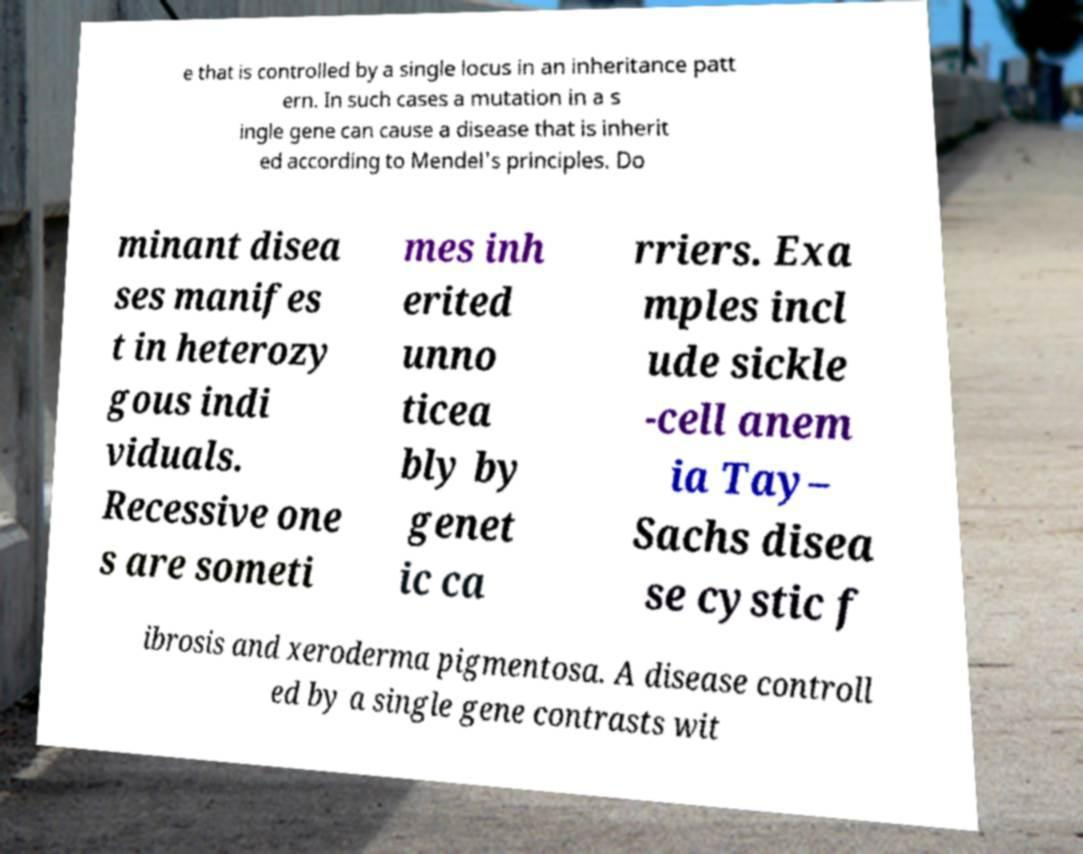I need the written content from this picture converted into text. Can you do that? e that is controlled by a single locus in an inheritance patt ern. In such cases a mutation in a s ingle gene can cause a disease that is inherit ed according to Mendel's principles. Do minant disea ses manifes t in heterozy gous indi viduals. Recessive one s are someti mes inh erited unno ticea bly by genet ic ca rriers. Exa mples incl ude sickle -cell anem ia Tay– Sachs disea se cystic f ibrosis and xeroderma pigmentosa. A disease controll ed by a single gene contrasts wit 